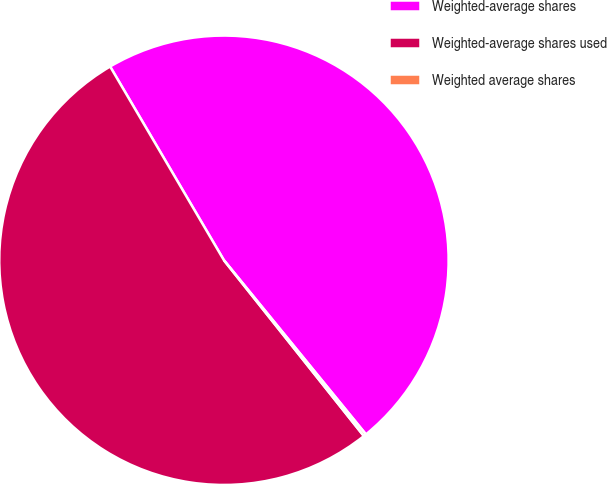Convert chart. <chart><loc_0><loc_0><loc_500><loc_500><pie_chart><fcel>Weighted-average shares<fcel>Weighted-average shares used<fcel>Weighted average shares<nl><fcel>47.56%<fcel>52.24%<fcel>0.19%<nl></chart> 